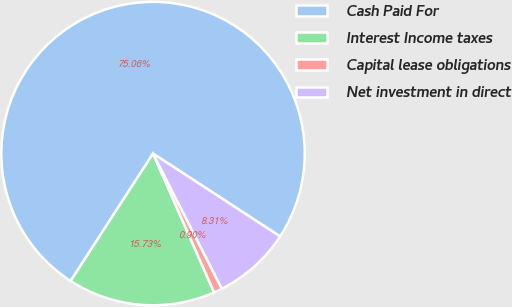<chart> <loc_0><loc_0><loc_500><loc_500><pie_chart><fcel>Cash Paid For<fcel>Interest Income taxes<fcel>Capital lease obligations<fcel>Net investment in direct<nl><fcel>75.06%<fcel>15.73%<fcel>0.9%<fcel>8.31%<nl></chart> 